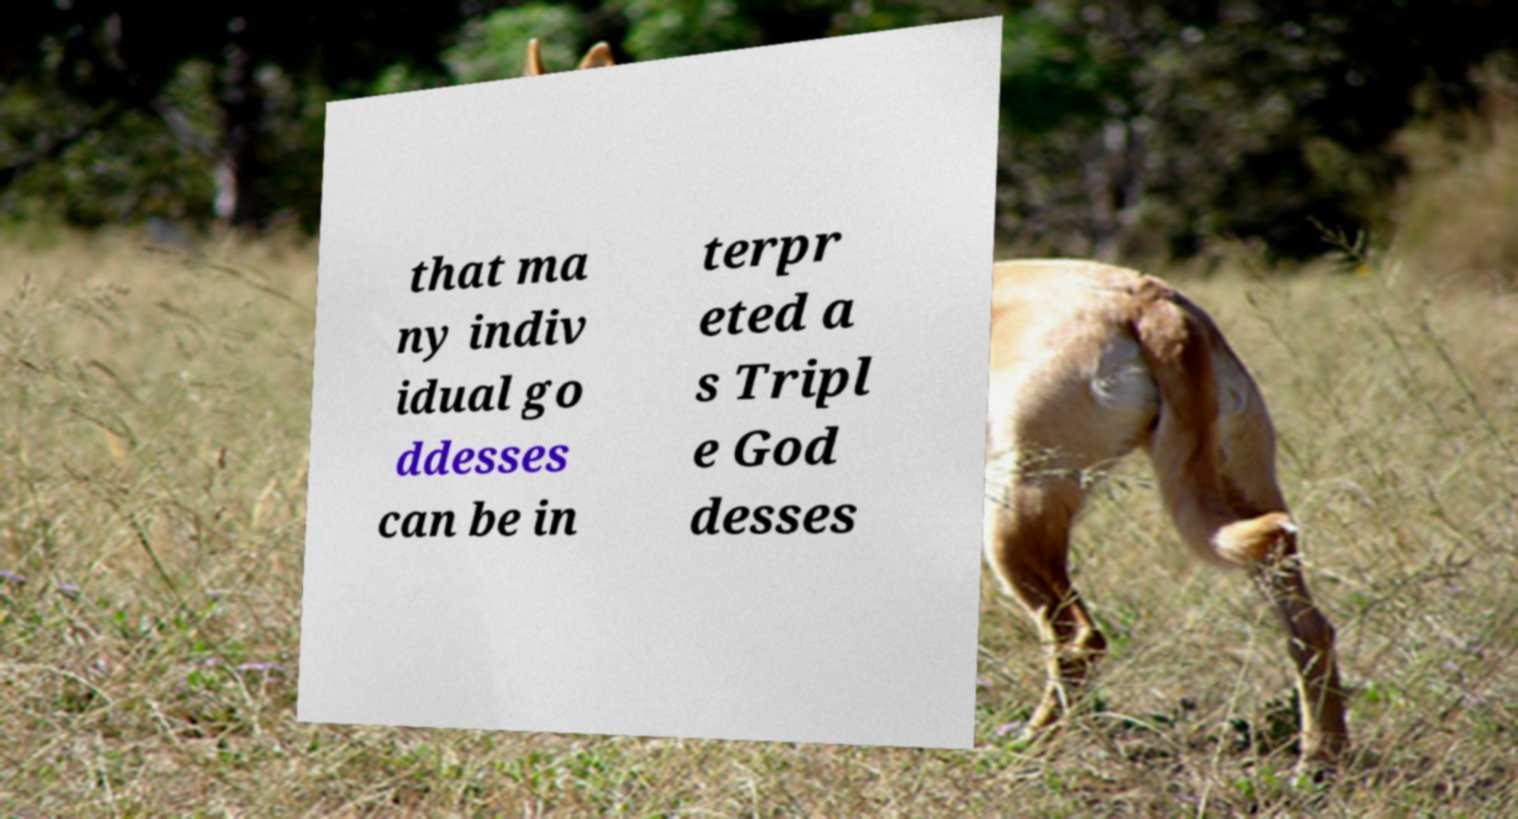What messages or text are displayed in this image? I need them in a readable, typed format. that ma ny indiv idual go ddesses can be in terpr eted a s Tripl e God desses 